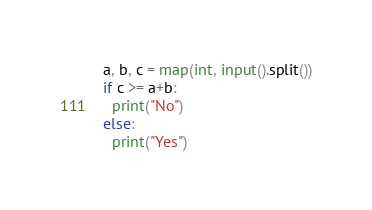<code> <loc_0><loc_0><loc_500><loc_500><_Python_>a, b, c = map(int, input().split())
if c >= a+b:
  print("No")
else:
  print("Yes")</code> 